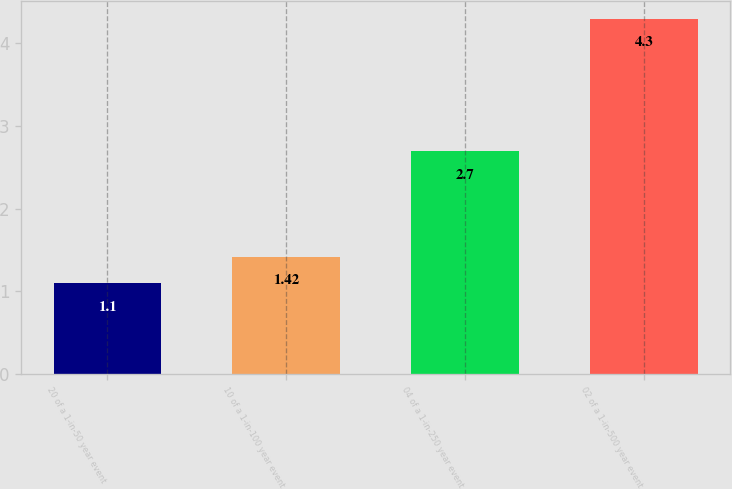Convert chart. <chart><loc_0><loc_0><loc_500><loc_500><bar_chart><fcel>20 of a 1-in-50 year event<fcel>10 of a 1-in-100 year event<fcel>04 of a 1-in-250 year event<fcel>02 of a 1-in-500 year event<nl><fcel>1.1<fcel>1.42<fcel>2.7<fcel>4.3<nl></chart> 